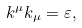Convert formula to latex. <formula><loc_0><loc_0><loc_500><loc_500>k ^ { \mu } k _ { \mu } = \varepsilon ,</formula> 